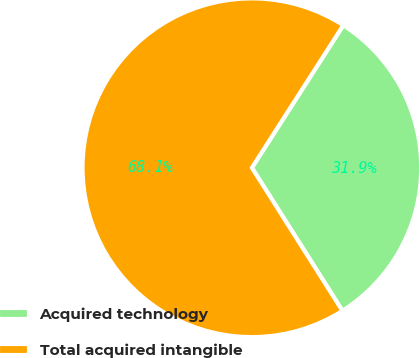Convert chart to OTSL. <chart><loc_0><loc_0><loc_500><loc_500><pie_chart><fcel>Acquired technology<fcel>Total acquired intangible<nl><fcel>31.94%<fcel>68.06%<nl></chart> 